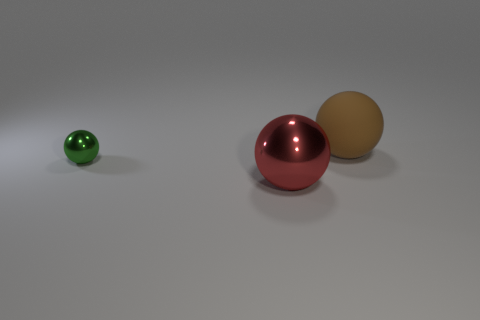There is another big thing that is the same shape as the big red thing; what is its material?
Your answer should be compact. Rubber. Are there any other things that are the same size as the green ball?
Give a very brief answer. No. Is the number of big brown rubber balls left of the tiny sphere less than the number of green shiny balls that are to the left of the red ball?
Your response must be concise. Yes. There is another tiny object that is made of the same material as the red thing; what is its shape?
Make the answer very short. Sphere. What color is the ball that is on the right side of the tiny shiny sphere and in front of the brown matte object?
Your answer should be compact. Red. Are the big sphere that is in front of the large brown object and the big brown thing made of the same material?
Your answer should be very brief. No. Are there fewer red things behind the large red ball than large red metallic objects?
Your response must be concise. Yes. Are there any other big objects made of the same material as the green object?
Make the answer very short. Yes. Do the green ball and the sphere on the right side of the red metallic sphere have the same size?
Keep it short and to the point. No. Is the tiny thing made of the same material as the red object?
Your answer should be very brief. Yes. 